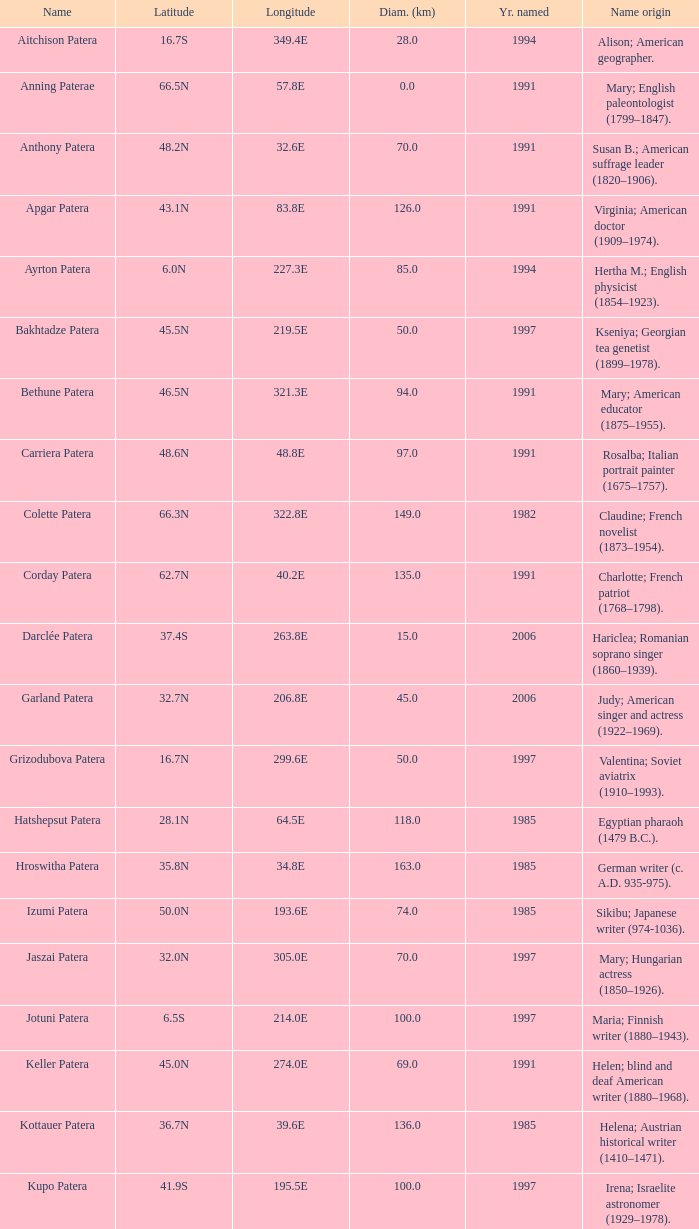What is the diameter in km of the feature named Colette Patera?  149.0. 